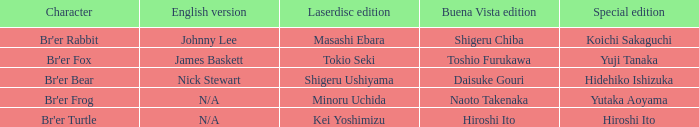Could you parse the entire table? {'header': ['Character', 'English version', 'Laserdisc edition', 'Buena Vista edition', 'Special edition'], 'rows': [["Br'er Rabbit", 'Johnny Lee', 'Masashi Ebara', 'Shigeru Chiba', 'Koichi Sakaguchi'], ["Br'er Fox", 'James Baskett', 'Tokio Seki', 'Toshio Furukawa', 'Yuji Tanaka'], ["Br'er Bear", 'Nick Stewart', 'Shigeru Ushiyama', 'Daisuke Gouri', 'Hidehiko Ishizuka'], ["Br'er Frog", 'N/A', 'Minoru Uchida', 'Naoto Takenaka', 'Yutaka Aoyama'], ["Br'er Turtle", 'N/A', 'Kei Yoshimizu', 'Hiroshi Ito', 'Hiroshi Ito']]} What is the special edition where the english version is nick stewart? Hidehiko Ishizuka. 